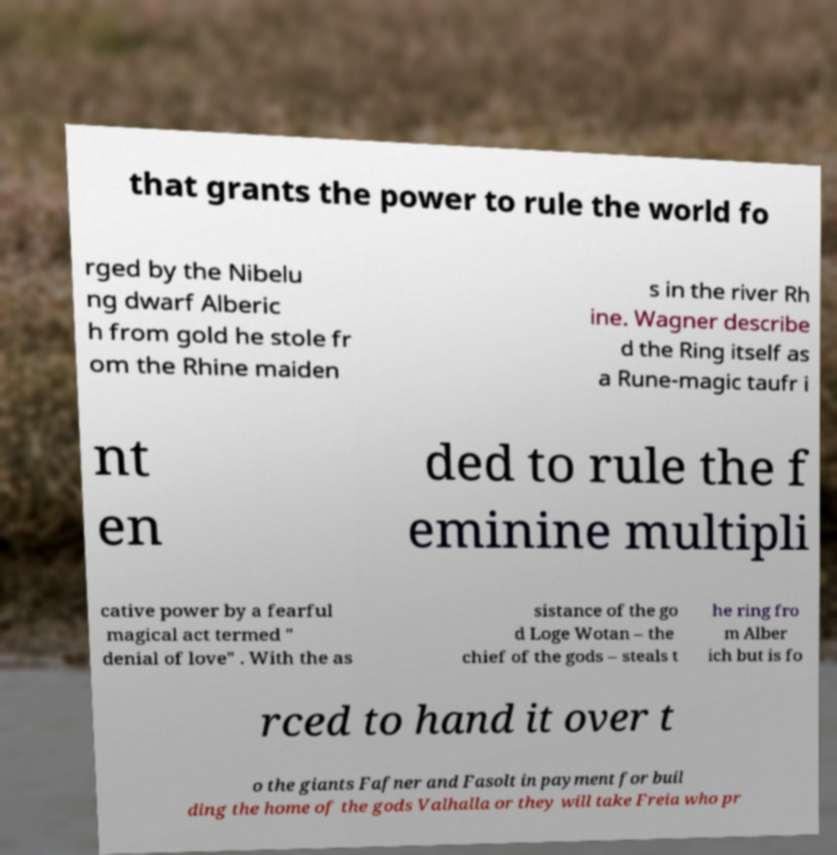Could you assist in decoding the text presented in this image and type it out clearly? that grants the power to rule the world fo rged by the Nibelu ng dwarf Alberic h from gold he stole fr om the Rhine maiden s in the river Rh ine. Wagner describe d the Ring itself as a Rune-magic taufr i nt en ded to rule the f eminine multipli cative power by a fearful magical act termed " denial of love" . With the as sistance of the go d Loge Wotan – the chief of the gods – steals t he ring fro m Alber ich but is fo rced to hand it over t o the giants Fafner and Fasolt in payment for buil ding the home of the gods Valhalla or they will take Freia who pr 